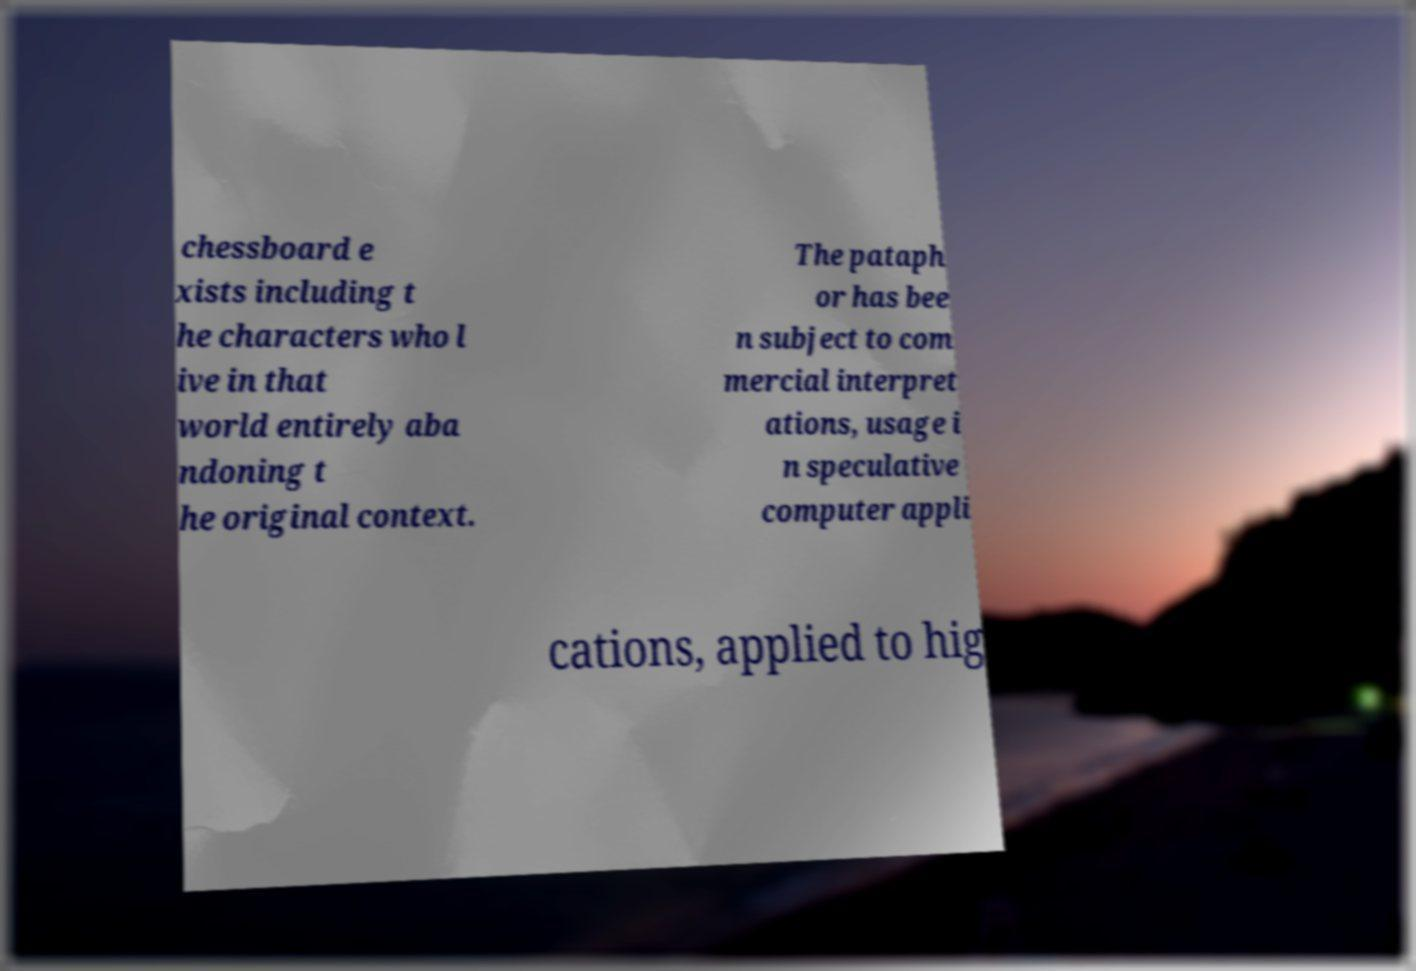What messages or text are displayed in this image? I need them in a readable, typed format. chessboard e xists including t he characters who l ive in that world entirely aba ndoning t he original context. The pataph or has bee n subject to com mercial interpret ations, usage i n speculative computer appli cations, applied to hig 